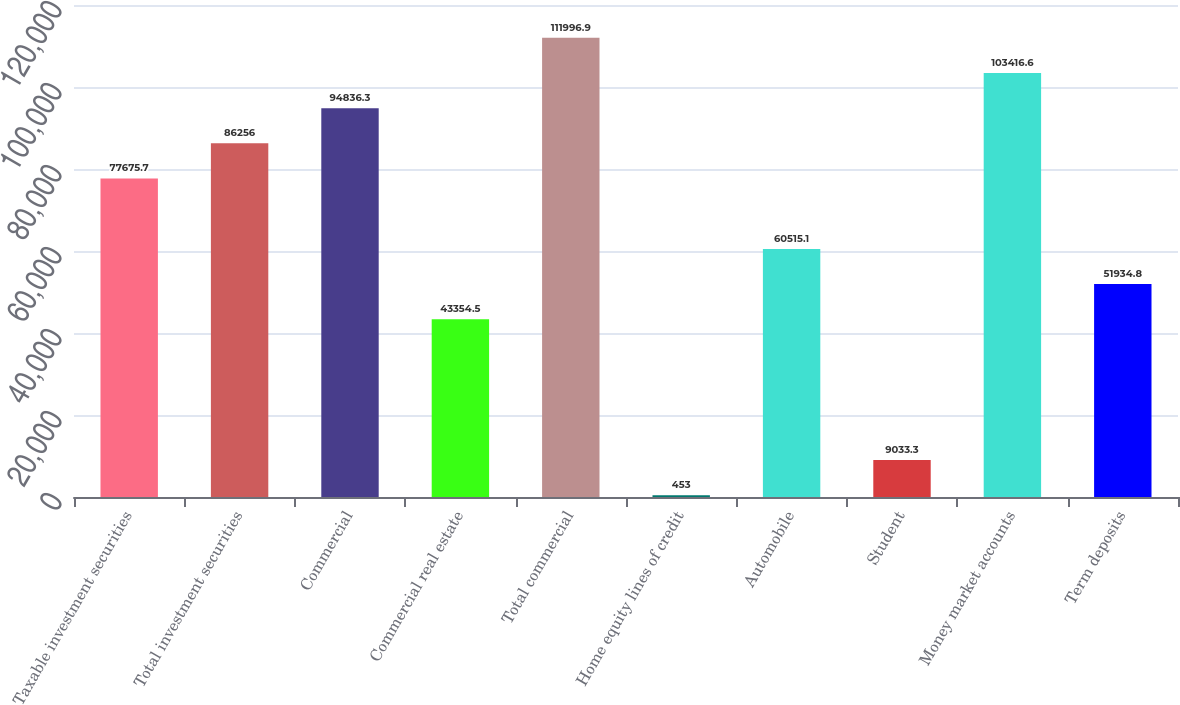Convert chart. <chart><loc_0><loc_0><loc_500><loc_500><bar_chart><fcel>Taxable investment securities<fcel>Total investment securities<fcel>Commercial<fcel>Commercial real estate<fcel>Total commercial<fcel>Home equity lines of credit<fcel>Automobile<fcel>Student<fcel>Money market accounts<fcel>Term deposits<nl><fcel>77675.7<fcel>86256<fcel>94836.3<fcel>43354.5<fcel>111997<fcel>453<fcel>60515.1<fcel>9033.3<fcel>103417<fcel>51934.8<nl></chart> 